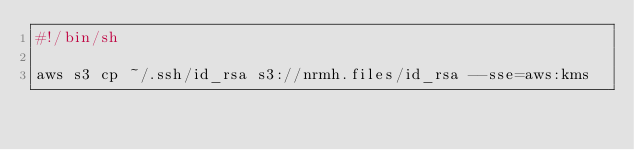Convert code to text. <code><loc_0><loc_0><loc_500><loc_500><_Bash_>#!/bin/sh

aws s3 cp ~/.ssh/id_rsa s3://nrmh.files/id_rsa --sse=aws:kms
</code> 